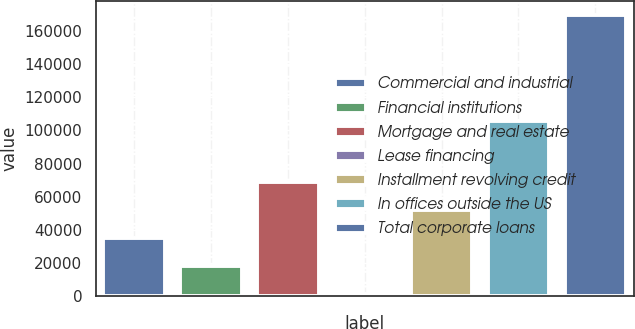Convert chart to OTSL. <chart><loc_0><loc_0><loc_500><loc_500><bar_chart><fcel>Commercial and industrial<fcel>Financial institutions<fcel>Mortgage and real estate<fcel>Lease financing<fcel>Installment revolving credit<fcel>In offices outside the US<fcel>Total corporate loans<nl><fcel>34981.8<fcel>18139.4<fcel>68666.6<fcel>1297<fcel>51824.2<fcel>105566<fcel>169721<nl></chart> 